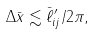<formula> <loc_0><loc_0><loc_500><loc_500>\Delta \bar { x } \lesssim \bar { \ell } ^ { \prime } _ { i j } / 2 \pi ,</formula> 